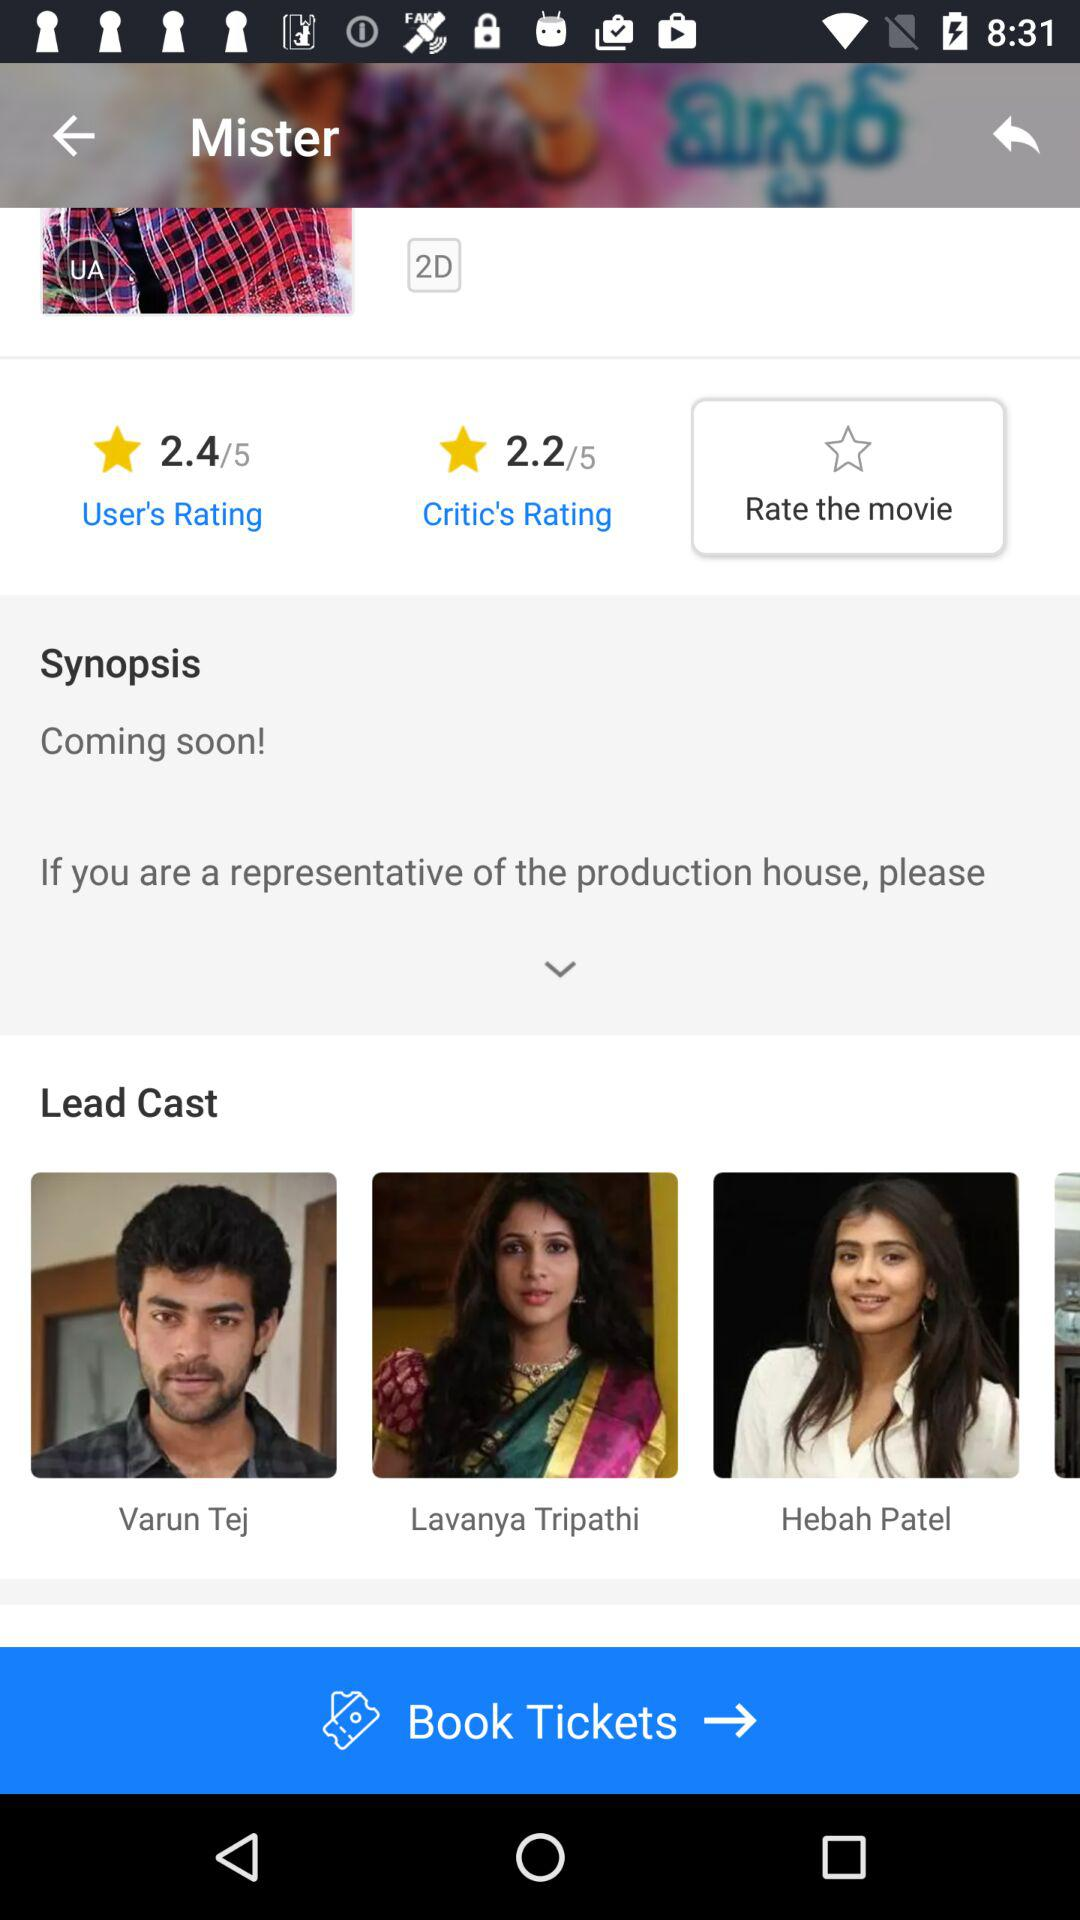In which dimension is the movie available? The movie is available in 2D. 